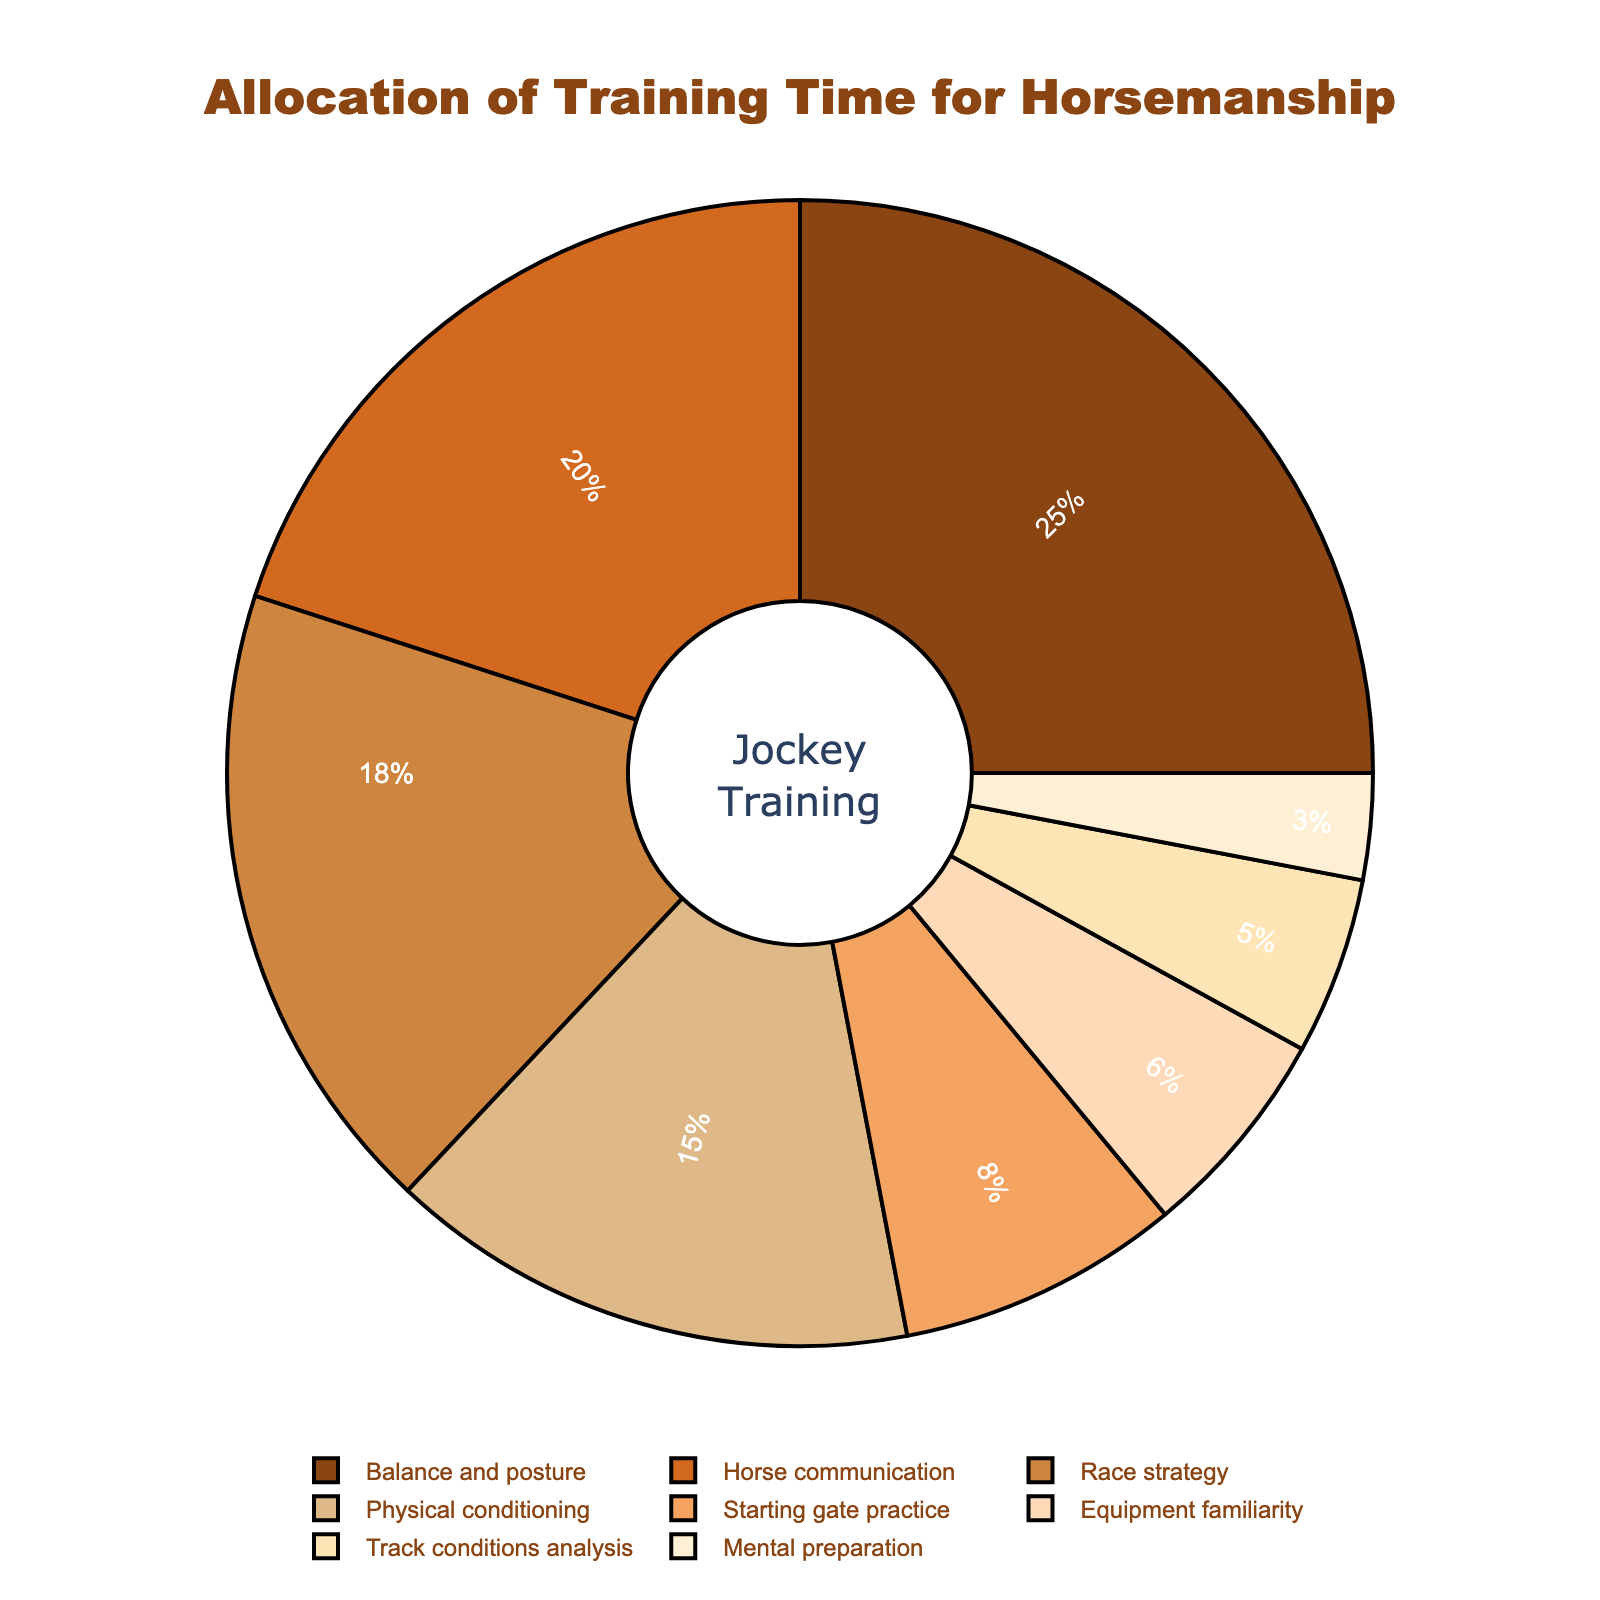What's the largest allocation of training time? The pie chart titles the different aspects of horsemanship training time allocations and their corresponding percentages. The largest portion is 'Balance and posture', indicating it has the highest allocation, which is 25%.
Answer: Balance and posture (25%) What's the total percentage for aspects related to race strategy and track conditions analysis? Looking at the chart, the 'Race strategy' has 18% and 'Track conditions analysis' has 5%. Adding these two percentages together gives 18% + 5% = 23%.
Answer: 23% Which aspect has a smaller training percentage, equipment familiarity, or horse communication? The chart shows 'Equipment familiarity' with 6% and 'Horse communication' with 20%. Since 6% is less than 20%, 'Equipment familiarity' has a smaller training percentage.
Answer: Equipment familiarity What is the combined training percentage of mental preparation, starting gate practice, and physical conditioning? The chart details 'Mental preparation' at 3%, 'Starting gate practice' at 8%, and 'Physical conditioning' at 15%. Summing these percentages: 3% + 8% + 15% = 26%.
Answer: 26% Does race strategy training receive more or less time than horse communication training? Comparing the pie sections, 'Race strategy' at 18% and 'Horse communication' at 20%, it is clear that 'Race strategy' receives less time than 'Horse communication', which is 20%.
Answer: Less What is the difference in training time allocation between balance and posture and mental preparation? The data provides 'Balance and posture' at 25% and 'Mental preparation' at 3%. The difference is 25% - 3% = 22%.
Answer: 22% Which two aspects together have a total training percentage of over 40%? Examining the chart, 'Balance and posture' has 25% and 'Horse communication' has 20%. Their combined total is 25% + 20% = 45%, which is over 40%.
Answer: Balance and posture and Horse communication Can you list the aspects that each receive more than 10% of the training time? From the pie chart, 'Balance and posture' (25%), 'Horse communication' (20%), 'Race strategy' (18%), and 'Physical conditioning' (15%) each have more than 10% allocated.
Answer: Balance and posture, Horse communication, Race strategy, Physical conditioning Which aspect of training has the least allocation? The smallest portion in the pie chart is 'Mental preparation' which is assigned 3%.
Answer: Mental preparation 